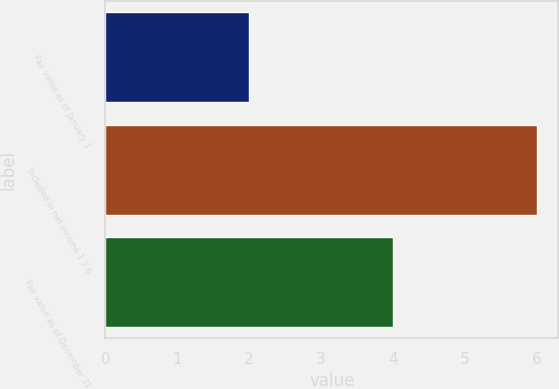<chart> <loc_0><loc_0><loc_500><loc_500><bar_chart><fcel>Fair value as of January 1<fcel>Included in net income 1 2 6<fcel>Fair value as of December 31<nl><fcel>2<fcel>6<fcel>4<nl></chart> 